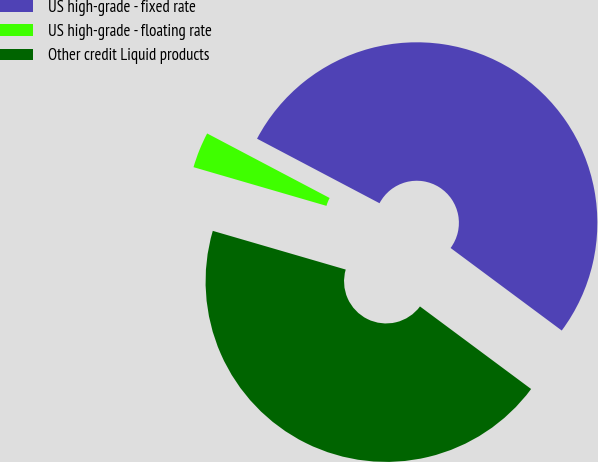<chart> <loc_0><loc_0><loc_500><loc_500><pie_chart><fcel>US high-grade - fixed rate<fcel>US high-grade - floating rate<fcel>Other credit Liquid products<nl><fcel>52.45%<fcel>3.21%<fcel>44.34%<nl></chart> 